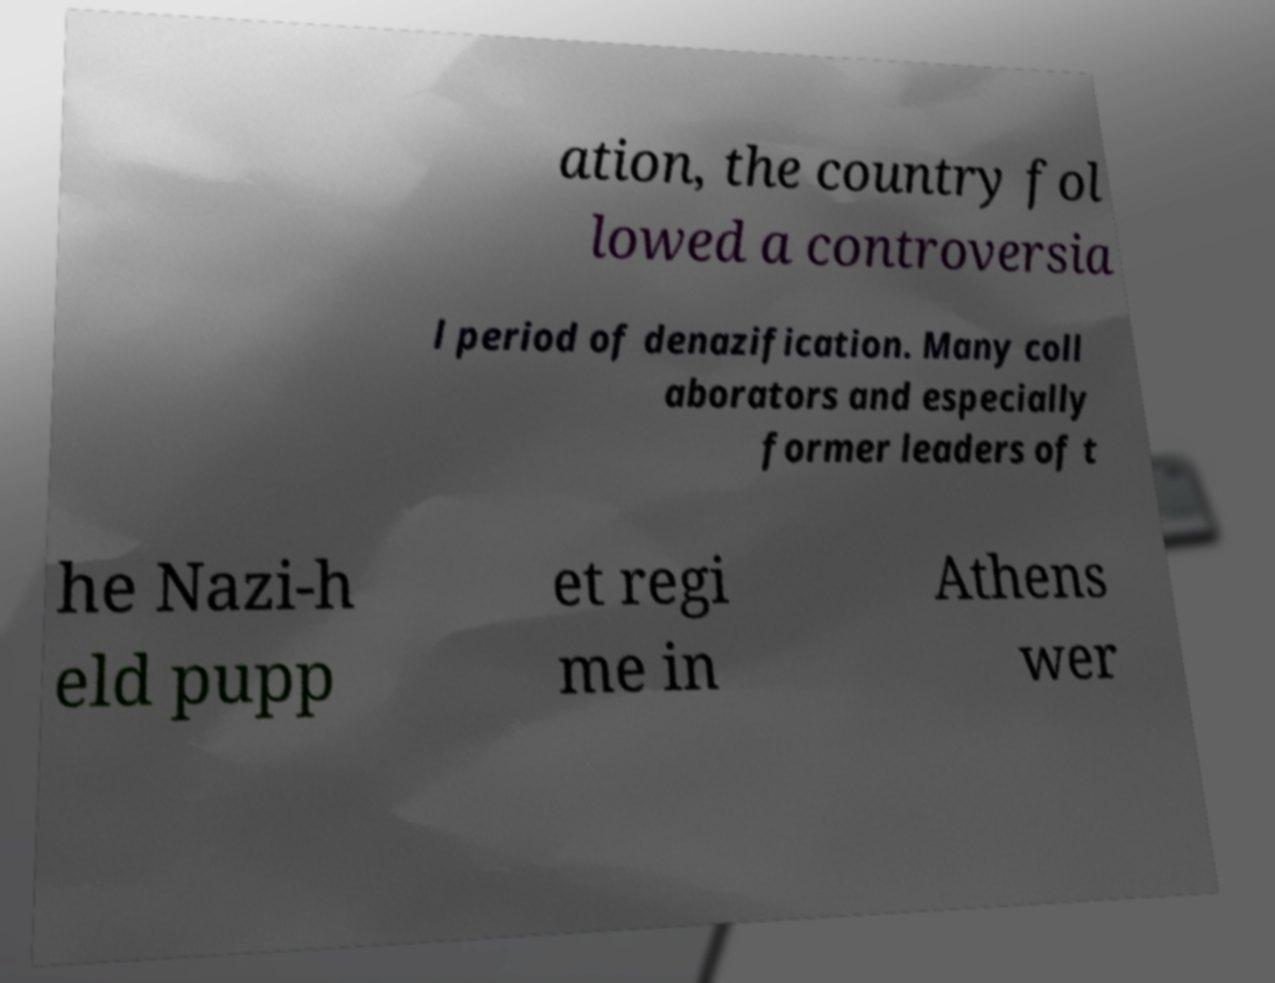Could you extract and type out the text from this image? ation, the country fol lowed a controversia l period of denazification. Many coll aborators and especially former leaders of t he Nazi-h eld pupp et regi me in Athens wer 